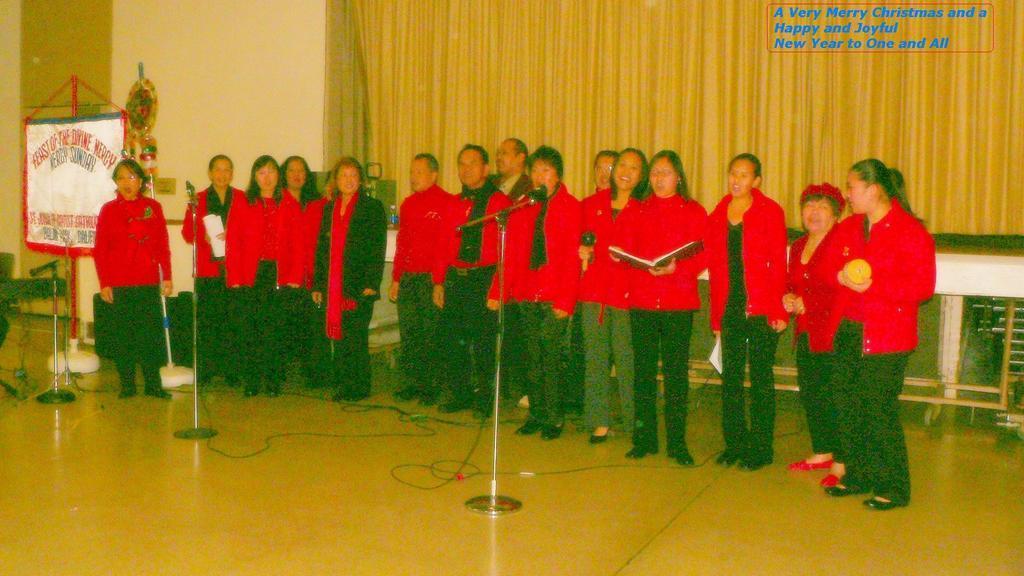Could you give a brief overview of what you see in this image? In this image there are a few people standing and few are holding some objects in their hand, in front of them there are mics. Beside them there is a banner with some text. In the background there is an object hanging on the wall, curtains and some text. 